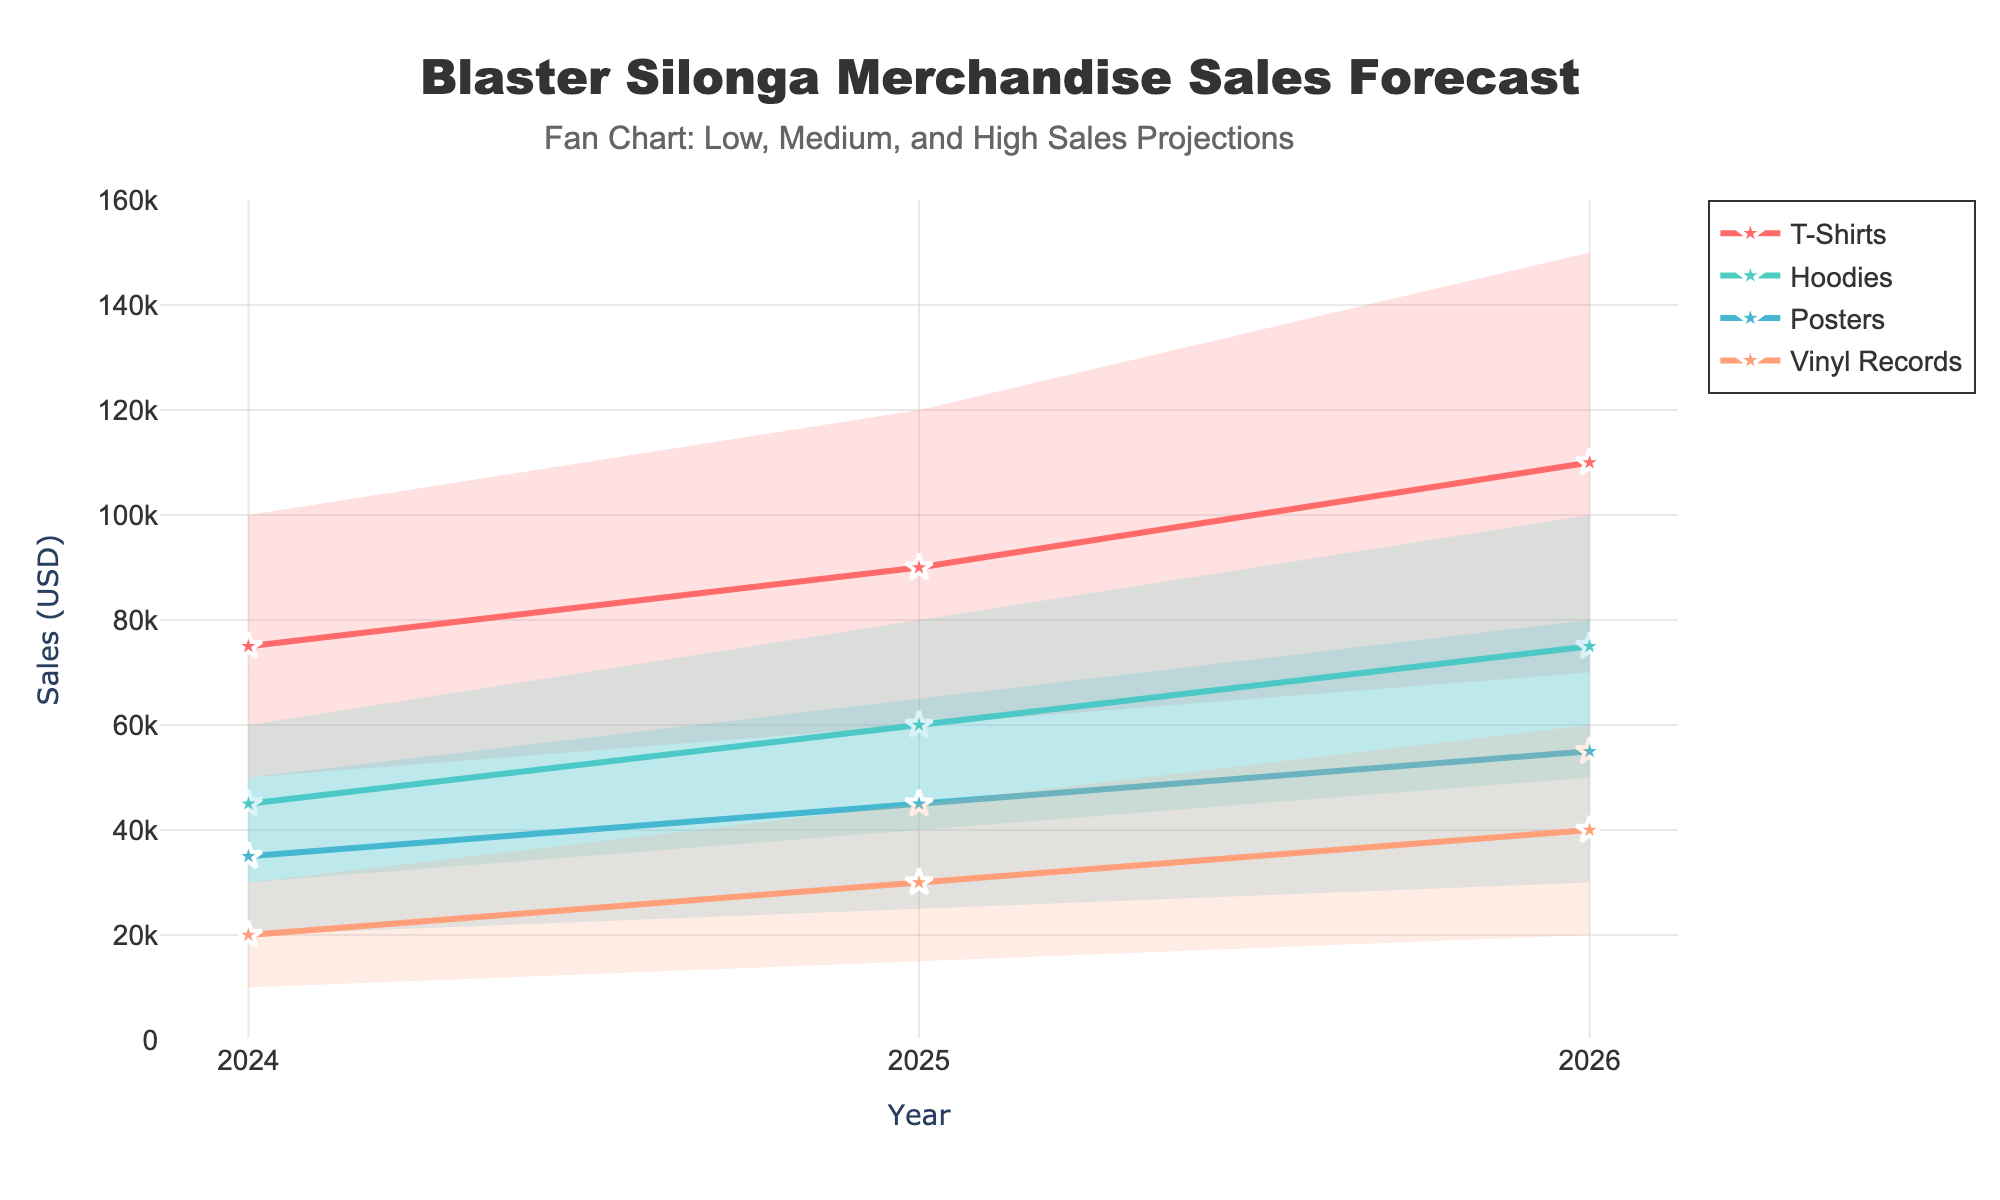What is the highest forecasted sales amount for T-Shirts in 2026? In 2026, the "High" forecast for T-Shirts is shown visually on the plot and corresponds to the highest boundary shaded region for that year. The value shown for the "High" forecast is 150,000 USD.
Answer: 150,000 USD How does the medium forecast for Hoodies change from 2024 to 2025? To find the change, we look at the medium forecast values for Hoodies in the given years and subtract the earlier value from the later value. The medium forecast for Hoodies is 45,000 USD in 2024 and 60,000 USD in 2025. Therefore, the change is 60,000 - 45,000 = 15,000 USD.
Answer: 15,000 USD Which merchandise category has the lowest low-end forecast in 2025? We examine the low-end forecast values for all categories in 2025. The values are: T-Shirts 60,000, Hoodies 40,000, Posters 25,000, and Vinyl Records 15,000. The lowest value is 15,000 for Vinyl Records.
Answer: Vinyl Records What is the title of the chart? The title of the chart is displayed prominently at the top of the plot. It reads "Blaster Silonga Merchandise Sales Forecast".
Answer: Blaster Silonga Merchandise Sales Forecast Which year has the highest medium forecast across all categories? To find this, we sum the medium forecasts for all categories for each year. Summing the medium values for each year: 2024 (75,000 + 45,000 + 35,000 + 20,000 = 175,000), 2025 (90,000 + 60,000 + 45,000 + 30,000 = 225,000), 2026 (110,000 + 75,000 + 55,000 + 40,000 = 280,000). The highest sum is for 2026 with 280,000 USD.
Answer: 2026 What are the colors used to represent different categories? Different categories are represented by distinct colors. Specifically, T-Shirts are usually red, Hoodies green, Posters blue, and Vinyl Records orange, based on the given color descriptions in the code.
Answer: Red, Green, Blue, Orange How wide is the forecast range for Posters in 2025? To determine the range width, we subtract the low forecast from the high forecast for Posters in 2025: 65,000 (High) - 25,000 (Low) = 40,000 USD.
Answer: 40,000 USD Which category is forecasted to have the most significant growth in medium sales from 2024 to 2026? We calculate the change in medium forecast values from 2024 to 2026 for each category: T-Shirts from 75,000 to 110,000 (35,000), Hoodies from 45,000 to 75,000 (30,000), Posters from 35,000 to 55,000 (20,000), Vinyl Records 20,000 to 40,000 (20,000). The most significant growth is for T-Shirts with an increase of 35,000 USD.
Answer: T-Shirts What is the forecasted medium sales amount for Vinyl Records in 2024? The medium forecast sales amount for Vinyl Records in 2024 can be directly found on the plot as 20,000 USD.
Answer: 20,000 USD Which category has the narrowest range of forecast values in 2024? To find this, we examine the ranges: T-Shirts (100,000 - 50,000 = 50,000), Hoodies (60,000 - 30,000 = 30,000), Posters (50,000 - 20,000 = 30,000), Vinyl Records (30,000 - 10,000 = 20,000). The narrowest range is for Vinyl Records with a range of 20,000 USD.
Answer: Vinyl Records 